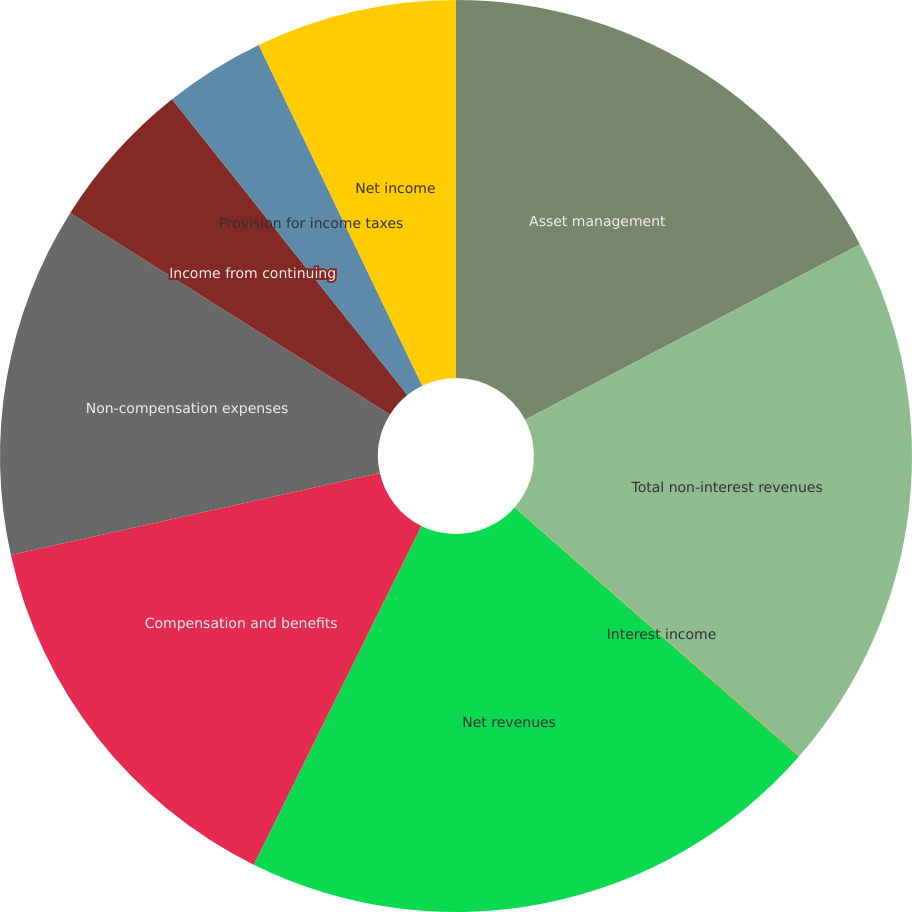<chart> <loc_0><loc_0><loc_500><loc_500><pie_chart><fcel>Asset management<fcel>Total non-interest revenues<fcel>Interest income<fcel>Net revenues<fcel>Compensation and benefits<fcel>Non-compensation expenses<fcel>Income from continuing<fcel>Provision for income taxes<fcel>Net income<nl><fcel>17.32%<fcel>19.09%<fcel>0.04%<fcel>20.86%<fcel>14.2%<fcel>12.43%<fcel>5.35%<fcel>3.58%<fcel>7.12%<nl></chart> 